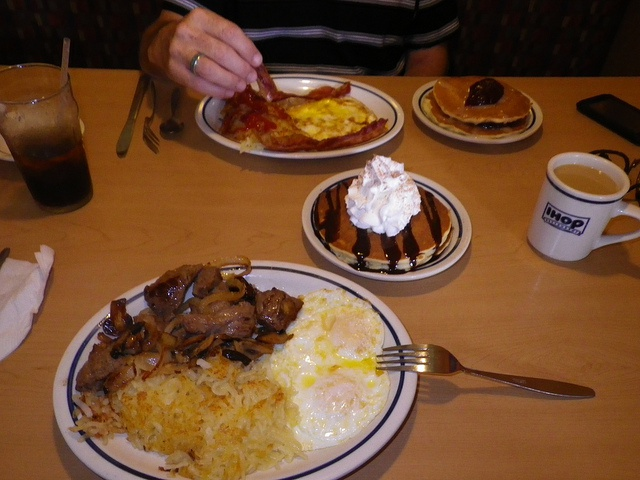Describe the objects in this image and their specific colors. I can see dining table in brown, black, and maroon tones, people in black, brown, maroon, and purple tones, cup in black, maroon, and brown tones, cup in black, gray, and brown tones, and fork in black, maroon, gray, and brown tones in this image. 